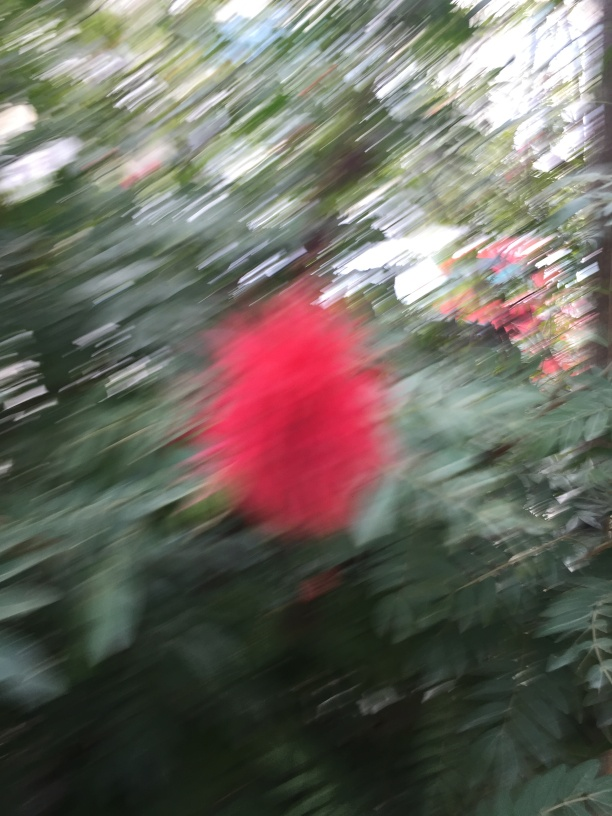Can you tell what the red object might be? While the specifics are obscured by the blur, the vibrant red hue could suggest it is a flower or perhaps a brightly colored man-made object. The surrounding green suggests a plant-heavy environment, potentially a garden or park. 